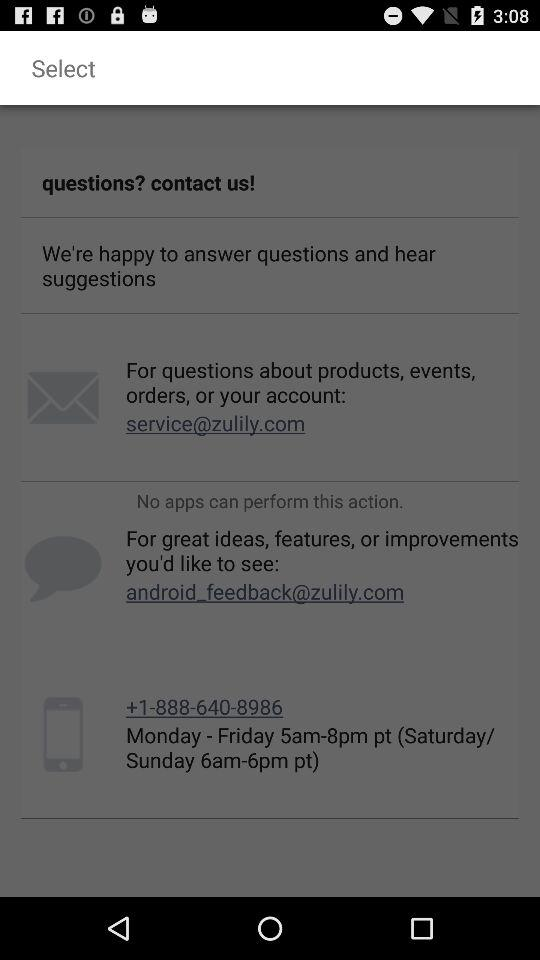How many contact options are there?
Answer the question using a single word or phrase. 3 